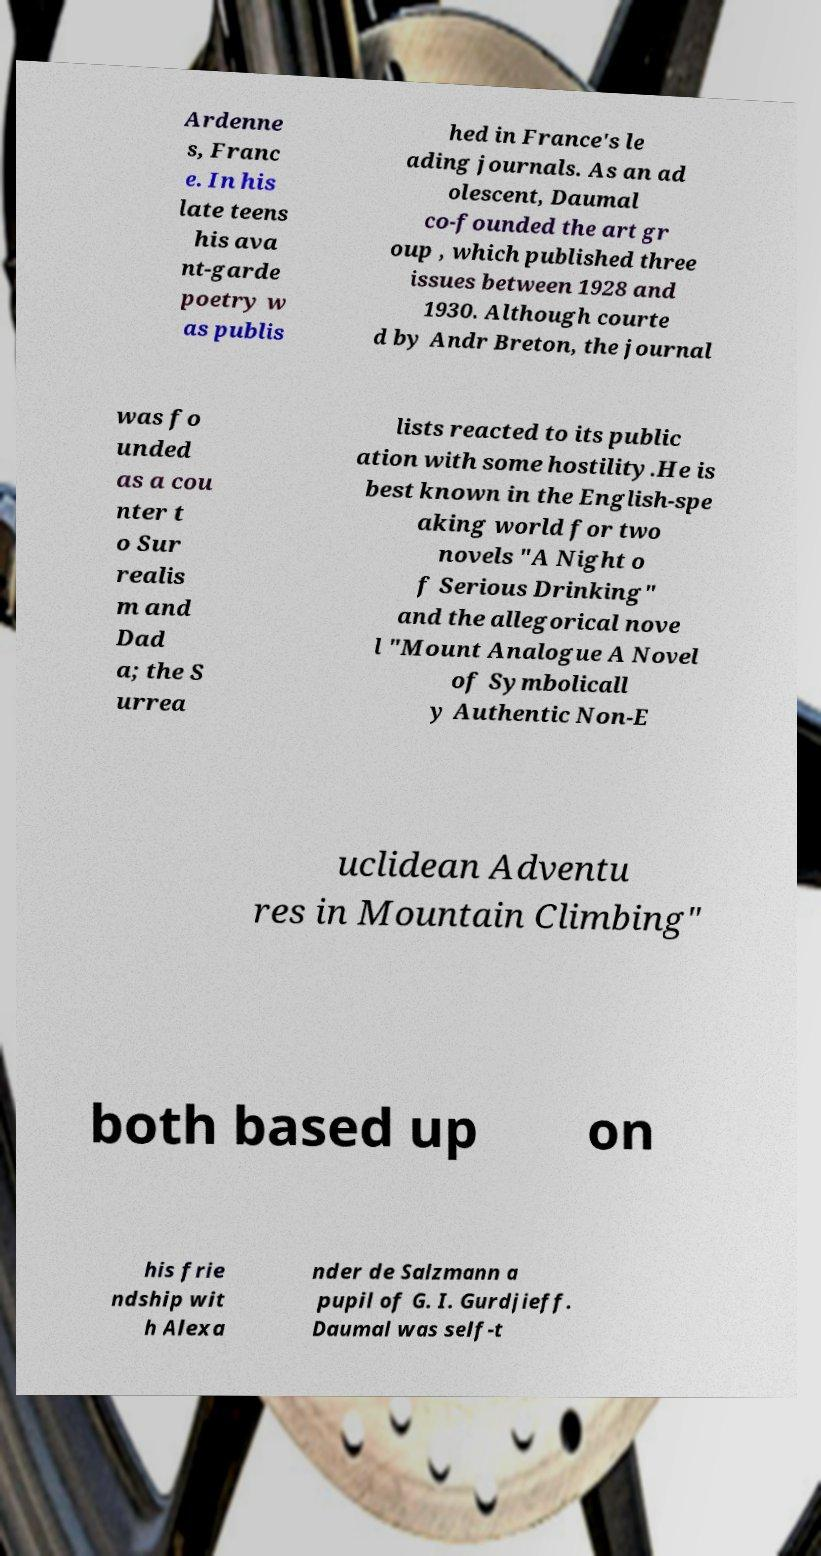Please identify and transcribe the text found in this image. Ardenne s, Franc e. In his late teens his ava nt-garde poetry w as publis hed in France's le ading journals. As an ad olescent, Daumal co-founded the art gr oup , which published three issues between 1928 and 1930. Although courte d by Andr Breton, the journal was fo unded as a cou nter t o Sur realis m and Dad a; the S urrea lists reacted to its public ation with some hostility.He is best known in the English-spe aking world for two novels "A Night o f Serious Drinking" and the allegorical nove l "Mount Analogue A Novel of Symbolicall y Authentic Non-E uclidean Adventu res in Mountain Climbing" both based up on his frie ndship wit h Alexa nder de Salzmann a pupil of G. I. Gurdjieff. Daumal was self-t 